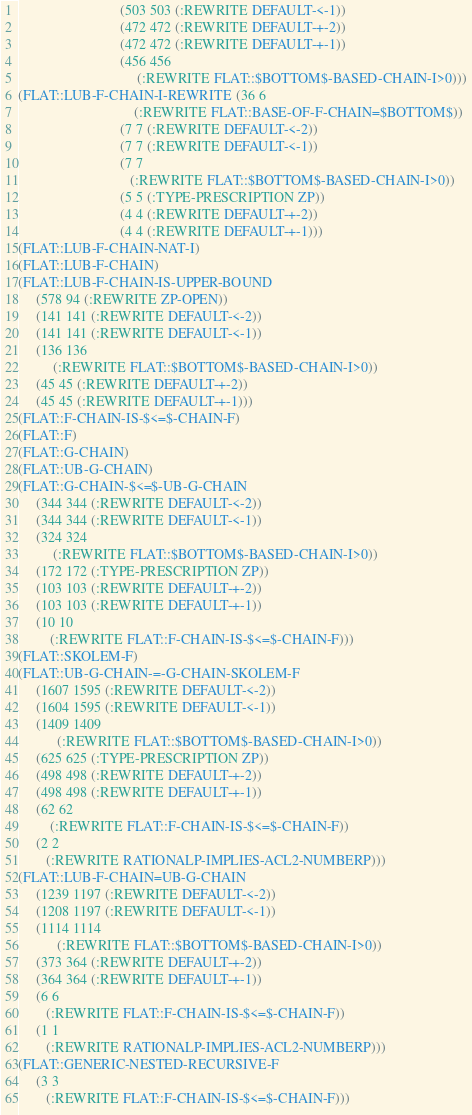<code> <loc_0><loc_0><loc_500><loc_500><_Lisp_>                             (503 503 (:REWRITE DEFAULT-<-1))
                             (472 472 (:REWRITE DEFAULT-+-2))
                             (472 472 (:REWRITE DEFAULT-+-1))
                             (456 456
                                  (:REWRITE FLAT::$BOTTOM$-BASED-CHAIN-I>0)))
(FLAT::LUB-F-CHAIN-I-REWRITE (36 6
                                 (:REWRITE FLAT::BASE-OF-F-CHAIN=$BOTTOM$))
                             (7 7 (:REWRITE DEFAULT-<-2))
                             (7 7 (:REWRITE DEFAULT-<-1))
                             (7 7
                                (:REWRITE FLAT::$BOTTOM$-BASED-CHAIN-I>0))
                             (5 5 (:TYPE-PRESCRIPTION ZP))
                             (4 4 (:REWRITE DEFAULT-+-2))
                             (4 4 (:REWRITE DEFAULT-+-1)))
(FLAT::LUB-F-CHAIN-NAT-I)
(FLAT::LUB-F-CHAIN)
(FLAT::LUB-F-CHAIN-IS-UPPER-BOUND
     (578 94 (:REWRITE ZP-OPEN))
     (141 141 (:REWRITE DEFAULT-<-2))
     (141 141 (:REWRITE DEFAULT-<-1))
     (136 136
          (:REWRITE FLAT::$BOTTOM$-BASED-CHAIN-I>0))
     (45 45 (:REWRITE DEFAULT-+-2))
     (45 45 (:REWRITE DEFAULT-+-1)))
(FLAT::F-CHAIN-IS-$<=$-CHAIN-F)
(FLAT::F)
(FLAT::G-CHAIN)
(FLAT::UB-G-CHAIN)
(FLAT::G-CHAIN-$<=$-UB-G-CHAIN
     (344 344 (:REWRITE DEFAULT-<-2))
     (344 344 (:REWRITE DEFAULT-<-1))
     (324 324
          (:REWRITE FLAT::$BOTTOM$-BASED-CHAIN-I>0))
     (172 172 (:TYPE-PRESCRIPTION ZP))
     (103 103 (:REWRITE DEFAULT-+-2))
     (103 103 (:REWRITE DEFAULT-+-1))
     (10 10
         (:REWRITE FLAT::F-CHAIN-IS-$<=$-CHAIN-F)))
(FLAT::SKOLEM-F)
(FLAT::UB-G-CHAIN-=-G-CHAIN-SKOLEM-F
     (1607 1595 (:REWRITE DEFAULT-<-2))
     (1604 1595 (:REWRITE DEFAULT-<-1))
     (1409 1409
           (:REWRITE FLAT::$BOTTOM$-BASED-CHAIN-I>0))
     (625 625 (:TYPE-PRESCRIPTION ZP))
     (498 498 (:REWRITE DEFAULT-+-2))
     (498 498 (:REWRITE DEFAULT-+-1))
     (62 62
         (:REWRITE FLAT::F-CHAIN-IS-$<=$-CHAIN-F))
     (2 2
        (:REWRITE RATIONALP-IMPLIES-ACL2-NUMBERP)))
(FLAT::LUB-F-CHAIN=UB-G-CHAIN
     (1239 1197 (:REWRITE DEFAULT-<-2))
     (1208 1197 (:REWRITE DEFAULT-<-1))
     (1114 1114
           (:REWRITE FLAT::$BOTTOM$-BASED-CHAIN-I>0))
     (373 364 (:REWRITE DEFAULT-+-2))
     (364 364 (:REWRITE DEFAULT-+-1))
     (6 6
        (:REWRITE FLAT::F-CHAIN-IS-$<=$-CHAIN-F))
     (1 1
        (:REWRITE RATIONALP-IMPLIES-ACL2-NUMBERP)))
(FLAT::GENERIC-NESTED-RECURSIVE-F
     (3 3
        (:REWRITE FLAT::F-CHAIN-IS-$<=$-CHAIN-F)))
</code> 